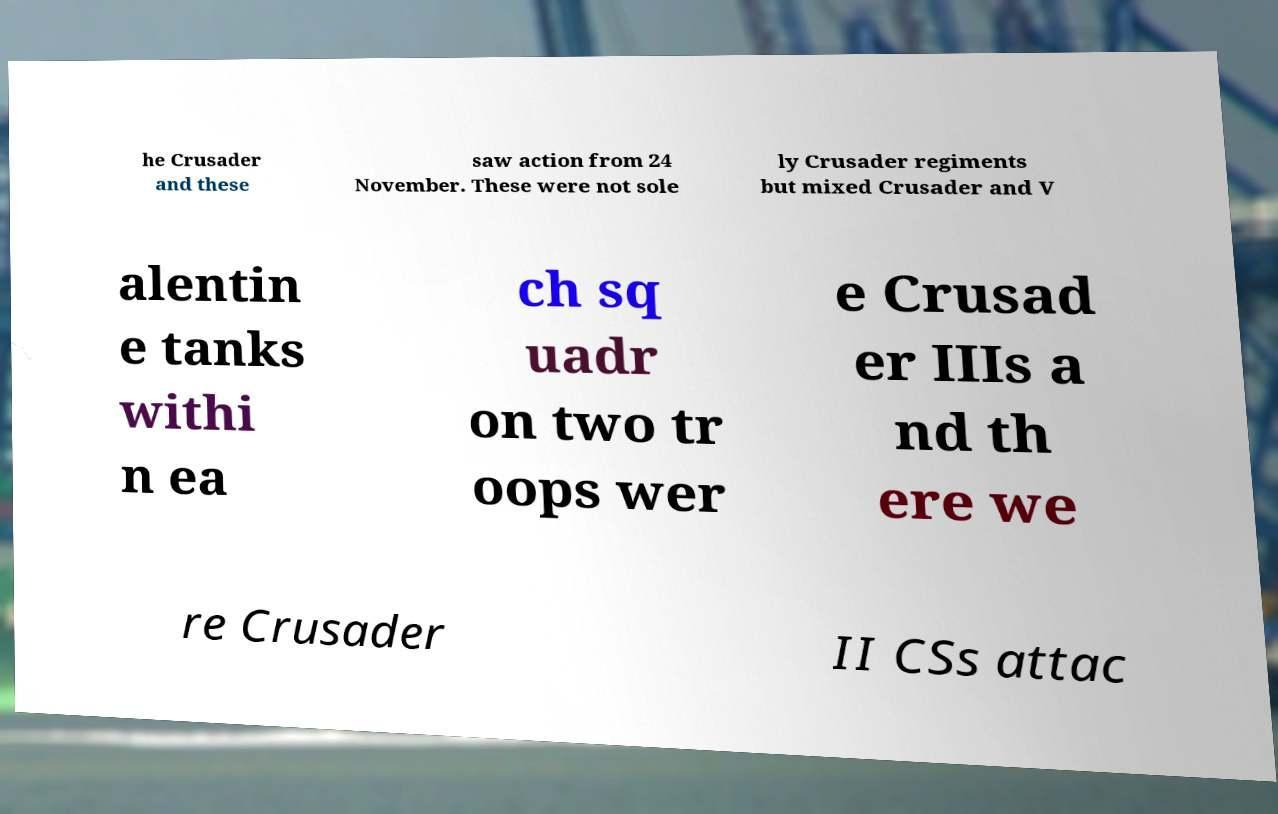There's text embedded in this image that I need extracted. Can you transcribe it verbatim? he Crusader and these saw action from 24 November. These were not sole ly Crusader regiments but mixed Crusader and V alentin e tanks withi n ea ch sq uadr on two tr oops wer e Crusad er IIIs a nd th ere we re Crusader II CSs attac 